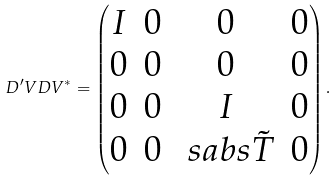<formula> <loc_0><loc_0><loc_500><loc_500>D ^ { \prime } V D V ^ { * } = \begin{pmatrix} I & 0 & 0 & 0 \\ 0 & 0 & 0 & 0 \\ 0 & 0 & I & 0 \\ 0 & 0 & \ s a b s { \tilde { T } } & 0 \\ \end{pmatrix} .</formula> 